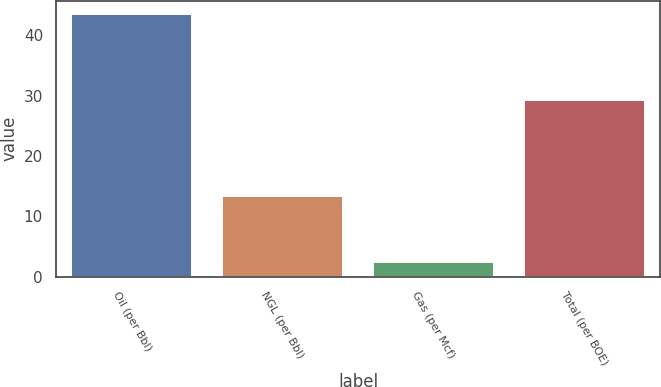Convert chart. <chart><loc_0><loc_0><loc_500><loc_500><bar_chart><fcel>Oil (per Bbl)<fcel>NGL (per Bbl)<fcel>Gas (per Mcf)<fcel>Total (per BOE)<nl><fcel>43.55<fcel>13.31<fcel>2.4<fcel>29.25<nl></chart> 